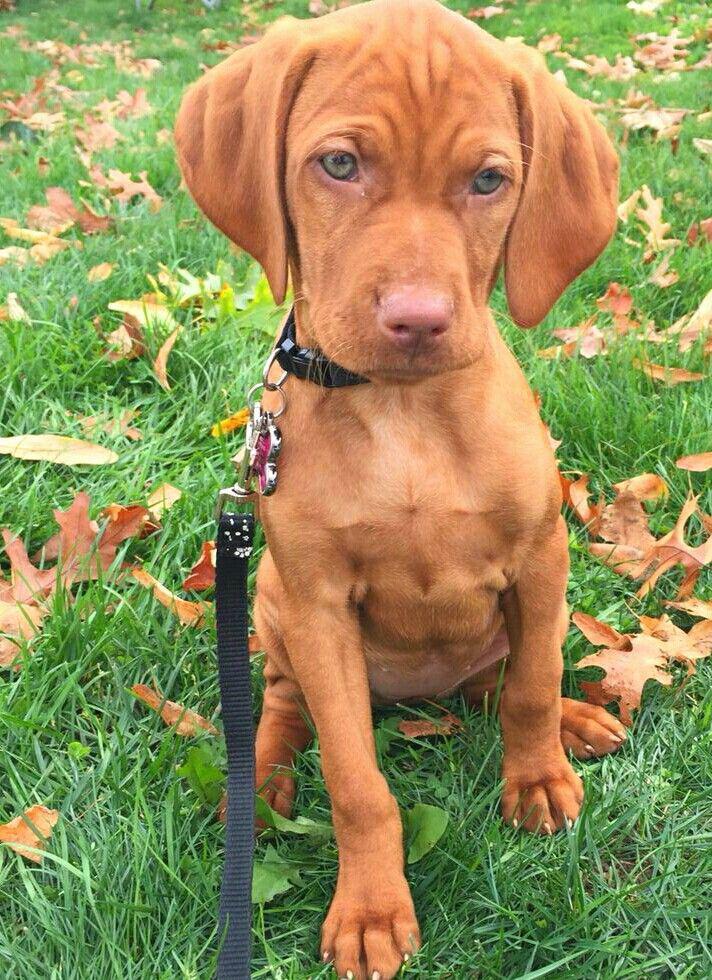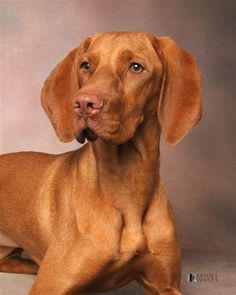The first image is the image on the left, the second image is the image on the right. Considering the images on both sides, is "A dog is wearing a red collar in the right image." valid? Answer yes or no. No. The first image is the image on the left, the second image is the image on the right. Considering the images on both sides, is "In at least one image there is a light brown puppy with a red and black collar sitting forward." valid? Answer yes or no. No. 